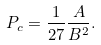<formula> <loc_0><loc_0><loc_500><loc_500>P _ { c } = \frac { 1 } { 2 7 } \frac { A } { B ^ { 2 } } .</formula> 